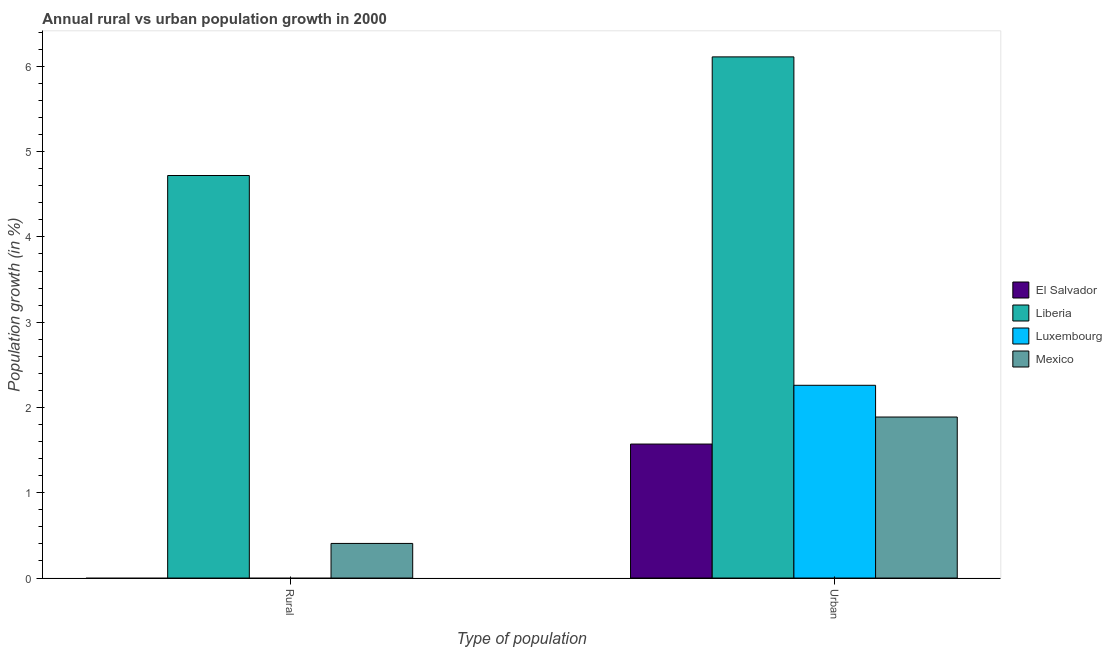How many different coloured bars are there?
Provide a succinct answer. 4. Are the number of bars on each tick of the X-axis equal?
Your answer should be compact. No. How many bars are there on the 2nd tick from the left?
Keep it short and to the point. 4. What is the label of the 2nd group of bars from the left?
Provide a short and direct response. Urban . What is the urban population growth in El Salvador?
Ensure brevity in your answer.  1.57. Across all countries, what is the maximum rural population growth?
Your answer should be very brief. 4.72. Across all countries, what is the minimum urban population growth?
Ensure brevity in your answer.  1.57. In which country was the rural population growth maximum?
Ensure brevity in your answer.  Liberia. What is the total rural population growth in the graph?
Offer a terse response. 5.13. What is the difference between the urban population growth in El Salvador and that in Luxembourg?
Keep it short and to the point. -0.69. What is the difference between the rural population growth in El Salvador and the urban population growth in Luxembourg?
Provide a short and direct response. -2.26. What is the average urban population growth per country?
Offer a very short reply. 2.96. What is the difference between the urban population growth and rural population growth in Liberia?
Your response must be concise. 1.39. In how many countries, is the urban population growth greater than 5.8 %?
Your answer should be very brief. 1. What is the ratio of the urban population growth in Luxembourg to that in Liberia?
Make the answer very short. 0.37. Is the urban population growth in El Salvador less than that in Mexico?
Make the answer very short. Yes. In how many countries, is the urban population growth greater than the average urban population growth taken over all countries?
Make the answer very short. 1. How many bars are there?
Offer a terse response. 6. How many countries are there in the graph?
Keep it short and to the point. 4. What is the difference between two consecutive major ticks on the Y-axis?
Ensure brevity in your answer.  1. Are the values on the major ticks of Y-axis written in scientific E-notation?
Provide a short and direct response. No. Does the graph contain any zero values?
Keep it short and to the point. Yes. What is the title of the graph?
Keep it short and to the point. Annual rural vs urban population growth in 2000. Does "Papua New Guinea" appear as one of the legend labels in the graph?
Offer a terse response. No. What is the label or title of the X-axis?
Give a very brief answer. Type of population. What is the label or title of the Y-axis?
Provide a short and direct response. Population growth (in %). What is the Population growth (in %) in El Salvador in Rural?
Ensure brevity in your answer.  0. What is the Population growth (in %) of Liberia in Rural?
Keep it short and to the point. 4.72. What is the Population growth (in %) of Mexico in Rural?
Your answer should be compact. 0.41. What is the Population growth (in %) in El Salvador in Urban ?
Give a very brief answer. 1.57. What is the Population growth (in %) of Liberia in Urban ?
Ensure brevity in your answer.  6.11. What is the Population growth (in %) in Luxembourg in Urban ?
Your response must be concise. 2.26. What is the Population growth (in %) of Mexico in Urban ?
Your answer should be very brief. 1.89. Across all Type of population, what is the maximum Population growth (in %) in El Salvador?
Offer a very short reply. 1.57. Across all Type of population, what is the maximum Population growth (in %) of Liberia?
Provide a succinct answer. 6.11. Across all Type of population, what is the maximum Population growth (in %) in Luxembourg?
Your answer should be very brief. 2.26. Across all Type of population, what is the maximum Population growth (in %) of Mexico?
Provide a short and direct response. 1.89. Across all Type of population, what is the minimum Population growth (in %) of Liberia?
Make the answer very short. 4.72. Across all Type of population, what is the minimum Population growth (in %) of Luxembourg?
Offer a very short reply. 0. Across all Type of population, what is the minimum Population growth (in %) of Mexico?
Provide a short and direct response. 0.41. What is the total Population growth (in %) of El Salvador in the graph?
Your response must be concise. 1.57. What is the total Population growth (in %) of Liberia in the graph?
Make the answer very short. 10.83. What is the total Population growth (in %) in Luxembourg in the graph?
Your answer should be compact. 2.26. What is the total Population growth (in %) of Mexico in the graph?
Offer a very short reply. 2.29. What is the difference between the Population growth (in %) in Liberia in Rural and that in Urban ?
Your answer should be compact. -1.39. What is the difference between the Population growth (in %) of Mexico in Rural and that in Urban ?
Make the answer very short. -1.48. What is the difference between the Population growth (in %) of Liberia in Rural and the Population growth (in %) of Luxembourg in Urban?
Ensure brevity in your answer.  2.46. What is the difference between the Population growth (in %) in Liberia in Rural and the Population growth (in %) in Mexico in Urban?
Offer a very short reply. 2.83. What is the average Population growth (in %) of El Salvador per Type of population?
Provide a short and direct response. 0.79. What is the average Population growth (in %) in Liberia per Type of population?
Keep it short and to the point. 5.42. What is the average Population growth (in %) of Luxembourg per Type of population?
Provide a short and direct response. 1.13. What is the average Population growth (in %) of Mexico per Type of population?
Ensure brevity in your answer.  1.15. What is the difference between the Population growth (in %) in Liberia and Population growth (in %) in Mexico in Rural?
Keep it short and to the point. 4.31. What is the difference between the Population growth (in %) of El Salvador and Population growth (in %) of Liberia in Urban ?
Provide a succinct answer. -4.54. What is the difference between the Population growth (in %) of El Salvador and Population growth (in %) of Luxembourg in Urban ?
Your answer should be very brief. -0.69. What is the difference between the Population growth (in %) in El Salvador and Population growth (in %) in Mexico in Urban ?
Your answer should be very brief. -0.32. What is the difference between the Population growth (in %) in Liberia and Population growth (in %) in Luxembourg in Urban ?
Offer a terse response. 3.85. What is the difference between the Population growth (in %) in Liberia and Population growth (in %) in Mexico in Urban ?
Offer a very short reply. 4.22. What is the difference between the Population growth (in %) in Luxembourg and Population growth (in %) in Mexico in Urban ?
Offer a terse response. 0.37. What is the ratio of the Population growth (in %) in Liberia in Rural to that in Urban ?
Offer a very short reply. 0.77. What is the ratio of the Population growth (in %) in Mexico in Rural to that in Urban ?
Offer a terse response. 0.21. What is the difference between the highest and the second highest Population growth (in %) of Liberia?
Ensure brevity in your answer.  1.39. What is the difference between the highest and the second highest Population growth (in %) of Mexico?
Give a very brief answer. 1.48. What is the difference between the highest and the lowest Population growth (in %) in El Salvador?
Your answer should be compact. 1.57. What is the difference between the highest and the lowest Population growth (in %) in Liberia?
Keep it short and to the point. 1.39. What is the difference between the highest and the lowest Population growth (in %) in Luxembourg?
Provide a short and direct response. 2.26. What is the difference between the highest and the lowest Population growth (in %) in Mexico?
Your answer should be compact. 1.48. 